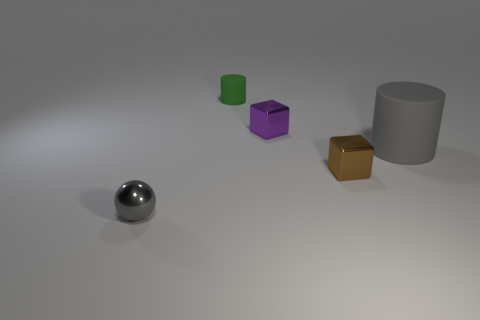Is the number of green objects to the right of the large rubber thing greater than the number of small purple blocks to the right of the purple cube?
Your response must be concise. No. What material is the tiny cube that is in front of the big matte cylinder?
Offer a terse response. Metal. Does the tiny green matte object have the same shape as the tiny brown metal thing?
Provide a short and direct response. No. Is there anything else that has the same color as the big object?
Give a very brief answer. Yes. What color is the large rubber thing that is the same shape as the small green rubber thing?
Make the answer very short. Gray. Are there more small purple metallic blocks that are on the right side of the purple block than big blue cubes?
Your response must be concise. No. What is the color of the matte cylinder in front of the small purple object?
Your answer should be very brief. Gray. Does the brown block have the same size as the purple shiny object?
Offer a terse response. Yes. How big is the gray cylinder?
Offer a terse response. Large. What shape is the object that is the same color as the big cylinder?
Provide a short and direct response. Sphere. 